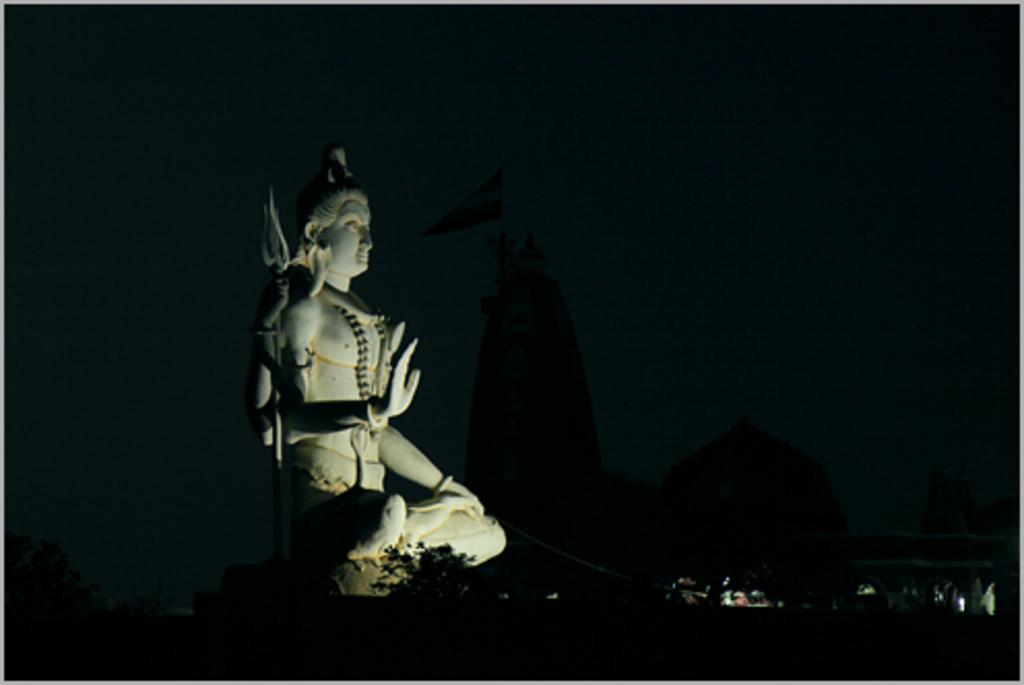What is the main subject in the image? There is a statue in the image. What new feature can be seen in the image? There are new lights in the image. What is the color of the background in the image? The background of the image is dark. What type of discovery can be seen in the image? There is no discovery present in the image; it features a statue and new lights. How many cattle are visible in the image? There are no cattle present in the image. 